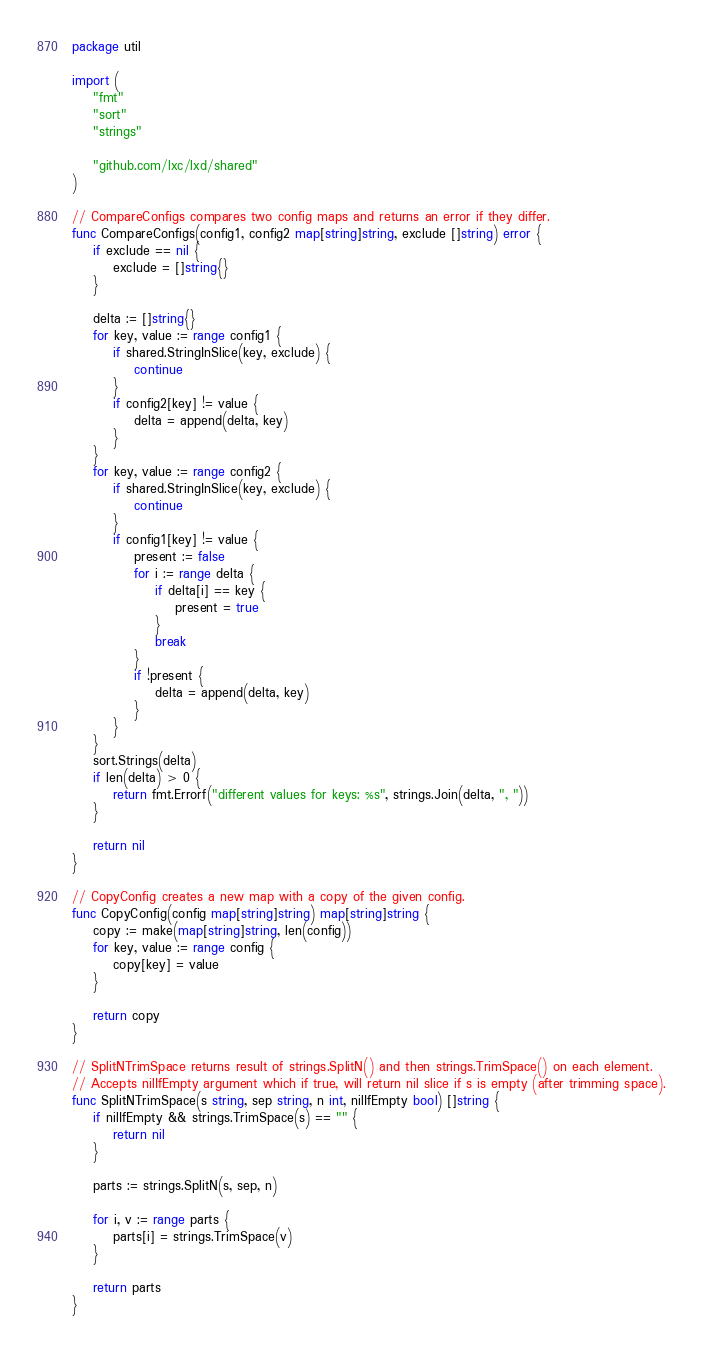<code> <loc_0><loc_0><loc_500><loc_500><_Go_>package util

import (
	"fmt"
	"sort"
	"strings"

	"github.com/lxc/lxd/shared"
)

// CompareConfigs compares two config maps and returns an error if they differ.
func CompareConfigs(config1, config2 map[string]string, exclude []string) error {
	if exclude == nil {
		exclude = []string{}
	}

	delta := []string{}
	for key, value := range config1 {
		if shared.StringInSlice(key, exclude) {
			continue
		}
		if config2[key] != value {
			delta = append(delta, key)
		}
	}
	for key, value := range config2 {
		if shared.StringInSlice(key, exclude) {
			continue
		}
		if config1[key] != value {
			present := false
			for i := range delta {
				if delta[i] == key {
					present = true
				}
				break
			}
			if !present {
				delta = append(delta, key)
			}
		}
	}
	sort.Strings(delta)
	if len(delta) > 0 {
		return fmt.Errorf("different values for keys: %s", strings.Join(delta, ", "))
	}

	return nil
}

// CopyConfig creates a new map with a copy of the given config.
func CopyConfig(config map[string]string) map[string]string {
	copy := make(map[string]string, len(config))
	for key, value := range config {
		copy[key] = value
	}

	return copy
}

// SplitNTrimSpace returns result of strings.SplitN() and then strings.TrimSpace() on each element.
// Accepts nilIfEmpty argument which if true, will return nil slice if s is empty (after trimming space).
func SplitNTrimSpace(s string, sep string, n int, nilIfEmpty bool) []string {
	if nilIfEmpty && strings.TrimSpace(s) == "" {
		return nil
	}

	parts := strings.SplitN(s, sep, n)

	for i, v := range parts {
		parts[i] = strings.TrimSpace(v)
	}

	return parts
}
</code> 